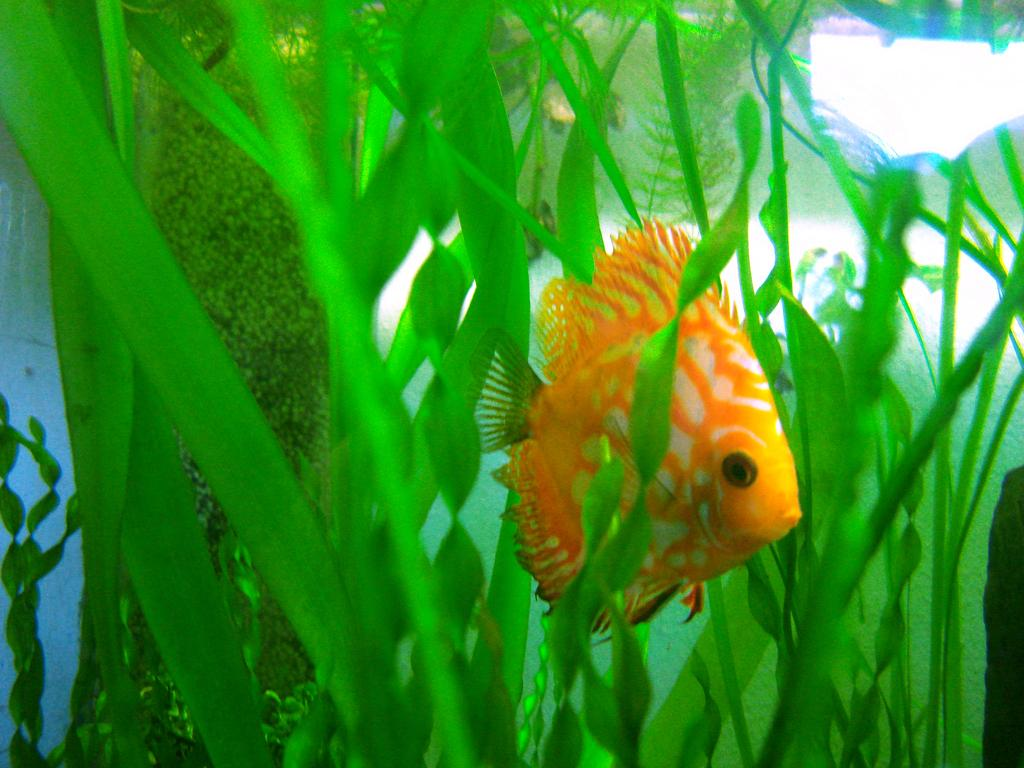What type of animal is in the image? There is a fish in the image. Can you describe the colors of the fish? The fish has orange and white colors. What is the environment surrounding the fish? There is water visible in the image. What type of vegetation is present in the image? There are green color plants in the image. How many slaves are visible in the image? There are no slaves present in the image; it features a fish in water with green plants. What type of sugar is being used to sweeten the water in the image? There is no sugar present in the image; it features a fish in water with green plants. 